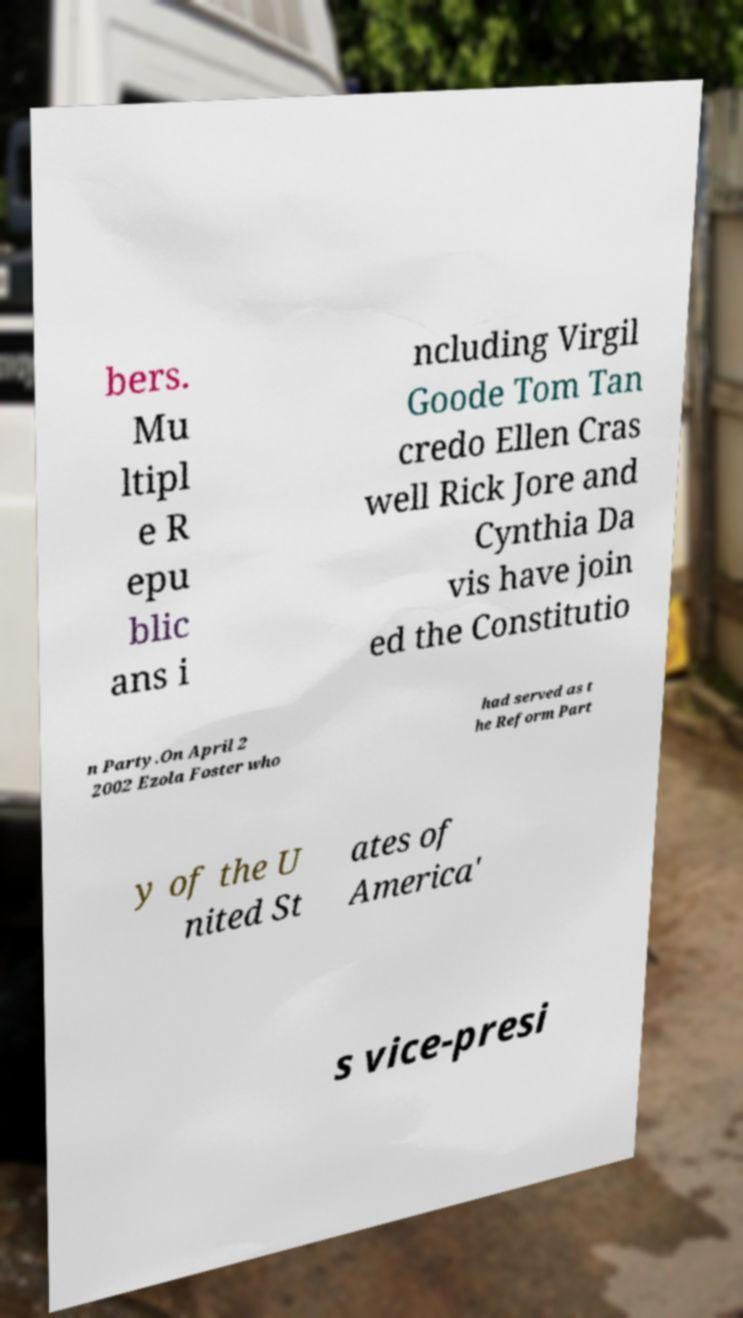Can you read and provide the text displayed in the image?This photo seems to have some interesting text. Can you extract and type it out for me? bers. Mu ltipl e R epu blic ans i ncluding Virgil Goode Tom Tan credo Ellen Cras well Rick Jore and Cynthia Da vis have join ed the Constitutio n Party.On April 2 2002 Ezola Foster who had served as t he Reform Part y of the U nited St ates of America' s vice-presi 